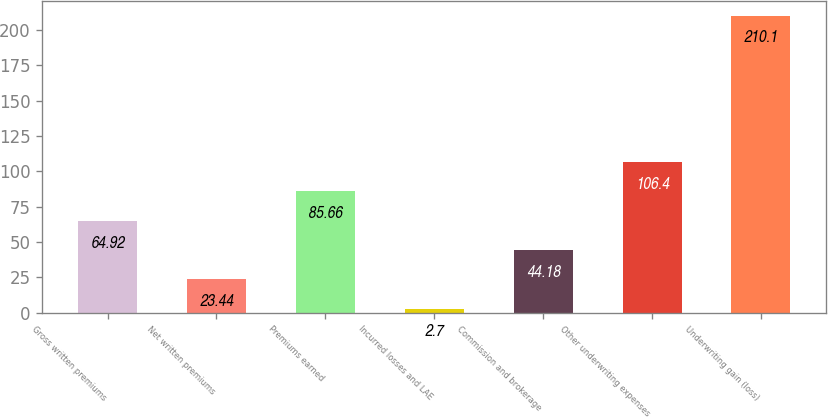Convert chart. <chart><loc_0><loc_0><loc_500><loc_500><bar_chart><fcel>Gross written premiums<fcel>Net written premiums<fcel>Premiums earned<fcel>Incurred losses and LAE<fcel>Commission and brokerage<fcel>Other underwriting expenses<fcel>Underwriting gain (loss)<nl><fcel>64.92<fcel>23.44<fcel>85.66<fcel>2.7<fcel>44.18<fcel>106.4<fcel>210.1<nl></chart> 